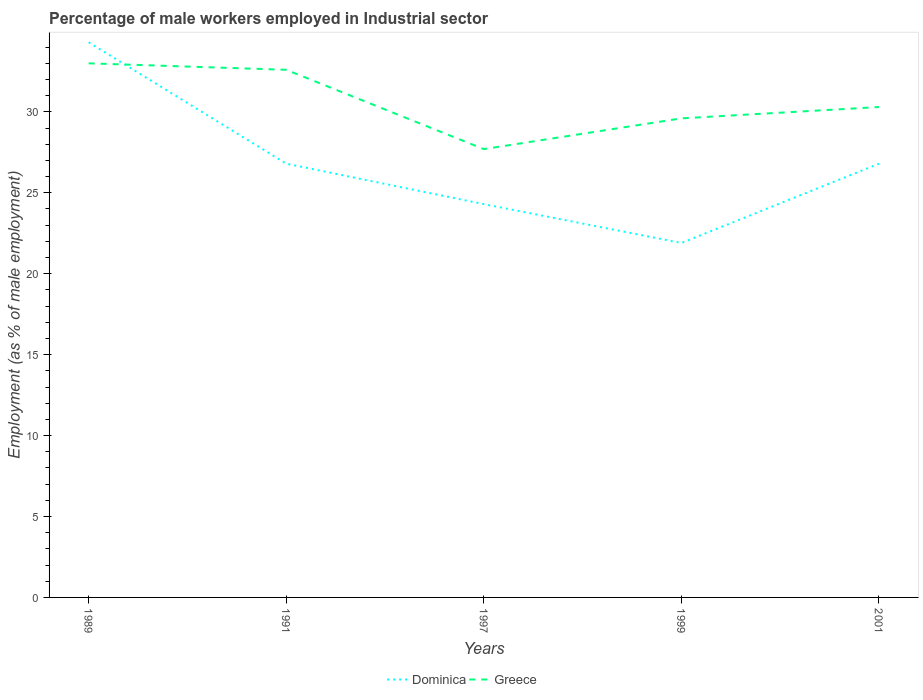How many different coloured lines are there?
Ensure brevity in your answer.  2. Across all years, what is the maximum percentage of male workers employed in Industrial sector in Dominica?
Your answer should be compact. 21.9. What is the total percentage of male workers employed in Industrial sector in Dominica in the graph?
Keep it short and to the point. 2.4. What is the difference between the highest and the second highest percentage of male workers employed in Industrial sector in Dominica?
Keep it short and to the point. 12.4. Is the percentage of male workers employed in Industrial sector in Greece strictly greater than the percentage of male workers employed in Industrial sector in Dominica over the years?
Make the answer very short. No. Are the values on the major ticks of Y-axis written in scientific E-notation?
Give a very brief answer. No. Does the graph contain grids?
Provide a short and direct response. No. Where does the legend appear in the graph?
Offer a very short reply. Bottom center. How are the legend labels stacked?
Your response must be concise. Horizontal. What is the title of the graph?
Give a very brief answer. Percentage of male workers employed in Industrial sector. What is the label or title of the X-axis?
Provide a succinct answer. Years. What is the label or title of the Y-axis?
Offer a terse response. Employment (as % of male employment). What is the Employment (as % of male employment) in Dominica in 1989?
Your answer should be compact. 34.3. What is the Employment (as % of male employment) of Dominica in 1991?
Keep it short and to the point. 26.8. What is the Employment (as % of male employment) in Greece in 1991?
Offer a terse response. 32.6. What is the Employment (as % of male employment) in Dominica in 1997?
Provide a short and direct response. 24.3. What is the Employment (as % of male employment) in Greece in 1997?
Provide a short and direct response. 27.7. What is the Employment (as % of male employment) of Dominica in 1999?
Give a very brief answer. 21.9. What is the Employment (as % of male employment) of Greece in 1999?
Offer a terse response. 29.6. What is the Employment (as % of male employment) of Dominica in 2001?
Your response must be concise. 26.8. What is the Employment (as % of male employment) in Greece in 2001?
Your answer should be compact. 30.3. Across all years, what is the maximum Employment (as % of male employment) in Dominica?
Provide a succinct answer. 34.3. Across all years, what is the minimum Employment (as % of male employment) in Dominica?
Make the answer very short. 21.9. Across all years, what is the minimum Employment (as % of male employment) of Greece?
Make the answer very short. 27.7. What is the total Employment (as % of male employment) of Dominica in the graph?
Provide a succinct answer. 134.1. What is the total Employment (as % of male employment) in Greece in the graph?
Make the answer very short. 153.2. What is the difference between the Employment (as % of male employment) of Dominica in 1989 and that in 1991?
Your response must be concise. 7.5. What is the difference between the Employment (as % of male employment) of Greece in 1989 and that in 1991?
Offer a very short reply. 0.4. What is the difference between the Employment (as % of male employment) of Greece in 1989 and that in 1999?
Offer a terse response. 3.4. What is the difference between the Employment (as % of male employment) of Greece in 1991 and that in 1999?
Your response must be concise. 3. What is the difference between the Employment (as % of male employment) of Dominica in 1991 and that in 2001?
Keep it short and to the point. 0. What is the difference between the Employment (as % of male employment) of Dominica in 1997 and that in 1999?
Give a very brief answer. 2.4. What is the difference between the Employment (as % of male employment) of Dominica in 1997 and that in 2001?
Provide a succinct answer. -2.5. What is the difference between the Employment (as % of male employment) of Greece in 1999 and that in 2001?
Keep it short and to the point. -0.7. What is the difference between the Employment (as % of male employment) of Dominica in 1991 and the Employment (as % of male employment) of Greece in 1997?
Keep it short and to the point. -0.9. What is the difference between the Employment (as % of male employment) of Dominica in 1991 and the Employment (as % of male employment) of Greece in 1999?
Provide a short and direct response. -2.8. What is the difference between the Employment (as % of male employment) of Dominica in 1997 and the Employment (as % of male employment) of Greece in 2001?
Provide a short and direct response. -6. What is the difference between the Employment (as % of male employment) of Dominica in 1999 and the Employment (as % of male employment) of Greece in 2001?
Provide a succinct answer. -8.4. What is the average Employment (as % of male employment) of Dominica per year?
Give a very brief answer. 26.82. What is the average Employment (as % of male employment) of Greece per year?
Ensure brevity in your answer.  30.64. In the year 1991, what is the difference between the Employment (as % of male employment) of Dominica and Employment (as % of male employment) of Greece?
Offer a terse response. -5.8. In the year 2001, what is the difference between the Employment (as % of male employment) of Dominica and Employment (as % of male employment) of Greece?
Provide a succinct answer. -3.5. What is the ratio of the Employment (as % of male employment) of Dominica in 1989 to that in 1991?
Provide a short and direct response. 1.28. What is the ratio of the Employment (as % of male employment) in Greece in 1989 to that in 1991?
Your response must be concise. 1.01. What is the ratio of the Employment (as % of male employment) of Dominica in 1989 to that in 1997?
Ensure brevity in your answer.  1.41. What is the ratio of the Employment (as % of male employment) of Greece in 1989 to that in 1997?
Offer a very short reply. 1.19. What is the ratio of the Employment (as % of male employment) of Dominica in 1989 to that in 1999?
Make the answer very short. 1.57. What is the ratio of the Employment (as % of male employment) in Greece in 1989 to that in 1999?
Keep it short and to the point. 1.11. What is the ratio of the Employment (as % of male employment) of Dominica in 1989 to that in 2001?
Offer a very short reply. 1.28. What is the ratio of the Employment (as % of male employment) of Greece in 1989 to that in 2001?
Ensure brevity in your answer.  1.09. What is the ratio of the Employment (as % of male employment) in Dominica in 1991 to that in 1997?
Your answer should be compact. 1.1. What is the ratio of the Employment (as % of male employment) in Greece in 1991 to that in 1997?
Your response must be concise. 1.18. What is the ratio of the Employment (as % of male employment) of Dominica in 1991 to that in 1999?
Ensure brevity in your answer.  1.22. What is the ratio of the Employment (as % of male employment) in Greece in 1991 to that in 1999?
Ensure brevity in your answer.  1.1. What is the ratio of the Employment (as % of male employment) in Greece in 1991 to that in 2001?
Your response must be concise. 1.08. What is the ratio of the Employment (as % of male employment) of Dominica in 1997 to that in 1999?
Keep it short and to the point. 1.11. What is the ratio of the Employment (as % of male employment) in Greece in 1997 to that in 1999?
Ensure brevity in your answer.  0.94. What is the ratio of the Employment (as % of male employment) in Dominica in 1997 to that in 2001?
Your response must be concise. 0.91. What is the ratio of the Employment (as % of male employment) in Greece in 1997 to that in 2001?
Offer a terse response. 0.91. What is the ratio of the Employment (as % of male employment) in Dominica in 1999 to that in 2001?
Your answer should be very brief. 0.82. What is the ratio of the Employment (as % of male employment) in Greece in 1999 to that in 2001?
Provide a short and direct response. 0.98. 